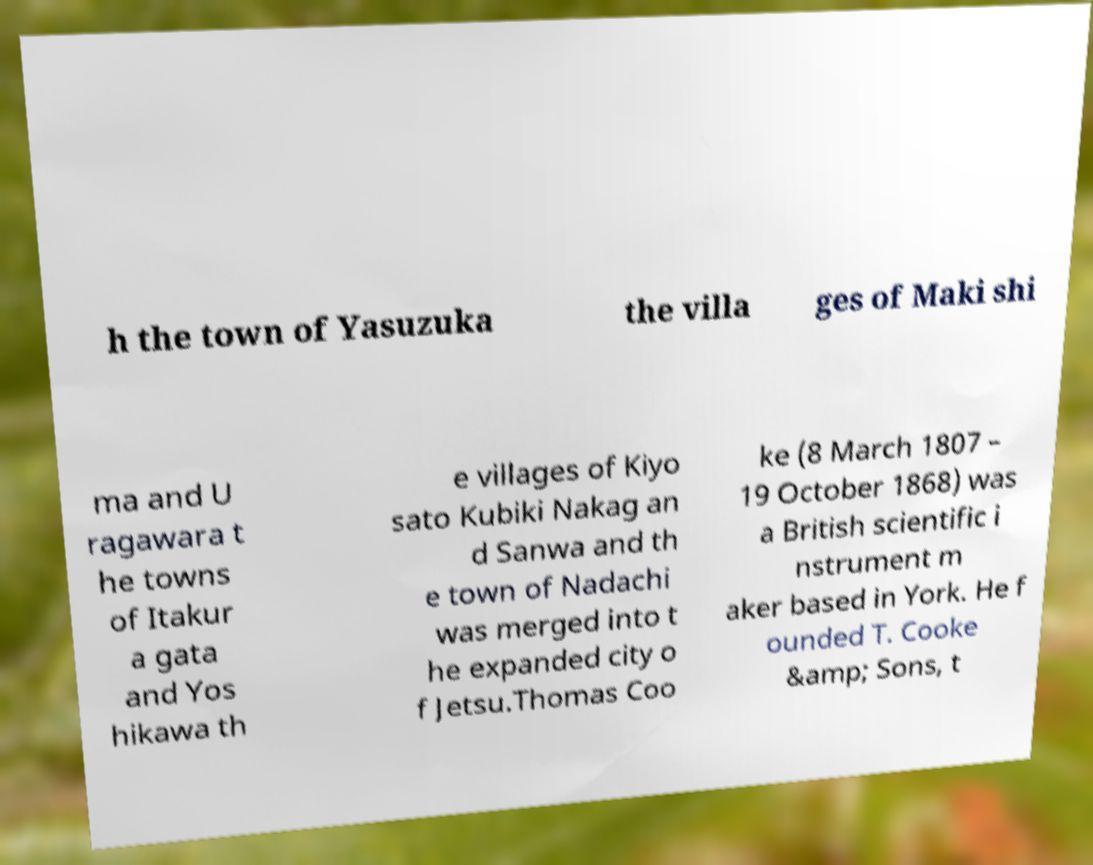Please identify and transcribe the text found in this image. h the town of Yasuzuka the villa ges of Maki shi ma and U ragawara t he towns of Itakur a gata and Yos hikawa th e villages of Kiyo sato Kubiki Nakag an d Sanwa and th e town of Nadachi was merged into t he expanded city o f Jetsu.Thomas Coo ke (8 March 1807 – 19 October 1868) was a British scientific i nstrument m aker based in York. He f ounded T. Cooke &amp; Sons, t 